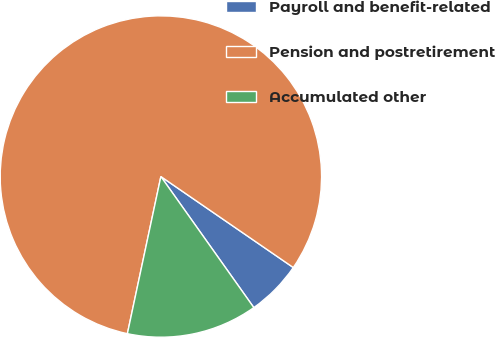<chart> <loc_0><loc_0><loc_500><loc_500><pie_chart><fcel>Payroll and benefit-related<fcel>Pension and postretirement<fcel>Accumulated other<nl><fcel>5.6%<fcel>81.24%<fcel>13.16%<nl></chart> 